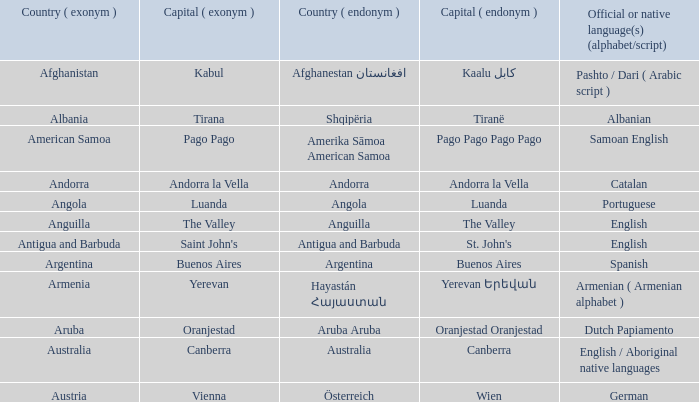Could you parse the entire table? {'header': ['Country ( exonym )', 'Capital ( exonym )', 'Country ( endonym )', 'Capital ( endonym )', 'Official or native language(s) (alphabet/script)'], 'rows': [['Afghanistan', 'Kabul', 'Afghanestan افغانستان', 'Kaalu كابل', 'Pashto / Dari ( Arabic script )'], ['Albania', 'Tirana', 'Shqipëria', 'Tiranë', 'Albanian'], ['American Samoa', 'Pago Pago', 'Amerika Sāmoa American Samoa', 'Pago Pago Pago Pago', 'Samoan English'], ['Andorra', 'Andorra la Vella', 'Andorra', 'Andorra la Vella', 'Catalan'], ['Angola', 'Luanda', 'Angola', 'Luanda', 'Portuguese'], ['Anguilla', 'The Valley', 'Anguilla', 'The Valley', 'English'], ['Antigua and Barbuda', "Saint John's", 'Antigua and Barbuda', "St. John's", 'English'], ['Argentina', 'Buenos Aires', 'Argentina', 'Buenos Aires', 'Spanish'], ['Armenia', 'Yerevan', 'Hayastán Հայաստան', 'Yerevan Երեվան', 'Armenian ( Armenian alphabet )'], ['Aruba', 'Oranjestad', 'Aruba Aruba', 'Oranjestad Oranjestad', 'Dutch Papiamento'], ['Australia', 'Canberra', 'Australia', 'Canberra', 'English / Aboriginal native languages'], ['Austria', 'Vienna', 'Österreich', 'Wien', 'German']]} What official or native languages are spoken in the country whose capital city is Canberra? English / Aboriginal native languages. 